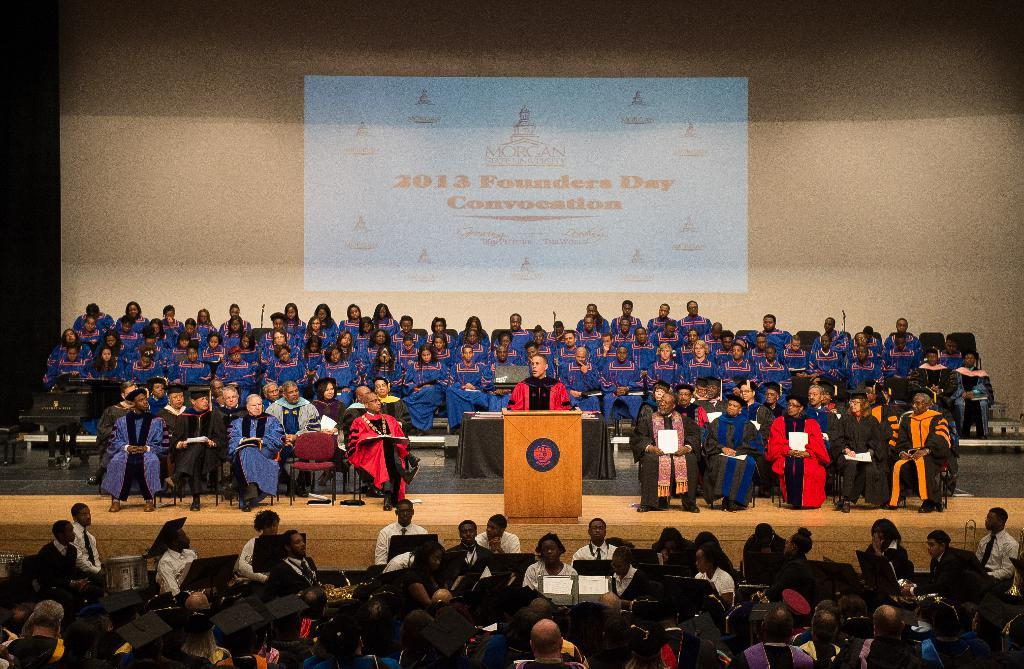What is the general arrangement of people in the image? There are groups of people in the image. What are the people doing in the image? The people are sitting on chairs. Can you describe the person standing behind a podium? There is a man standing behind a podium. What is visible behind the people in the image? There is a screen visible behind the people. What time of day is it in the image, and is it morning? The time of day is not mentioned or depicted in the image, so it cannot be determined if it is morning. How many bookshelves are present in the image, and is it a library? There is no mention of bookshelves or a library in the image, so it cannot be determined if it is a library. 